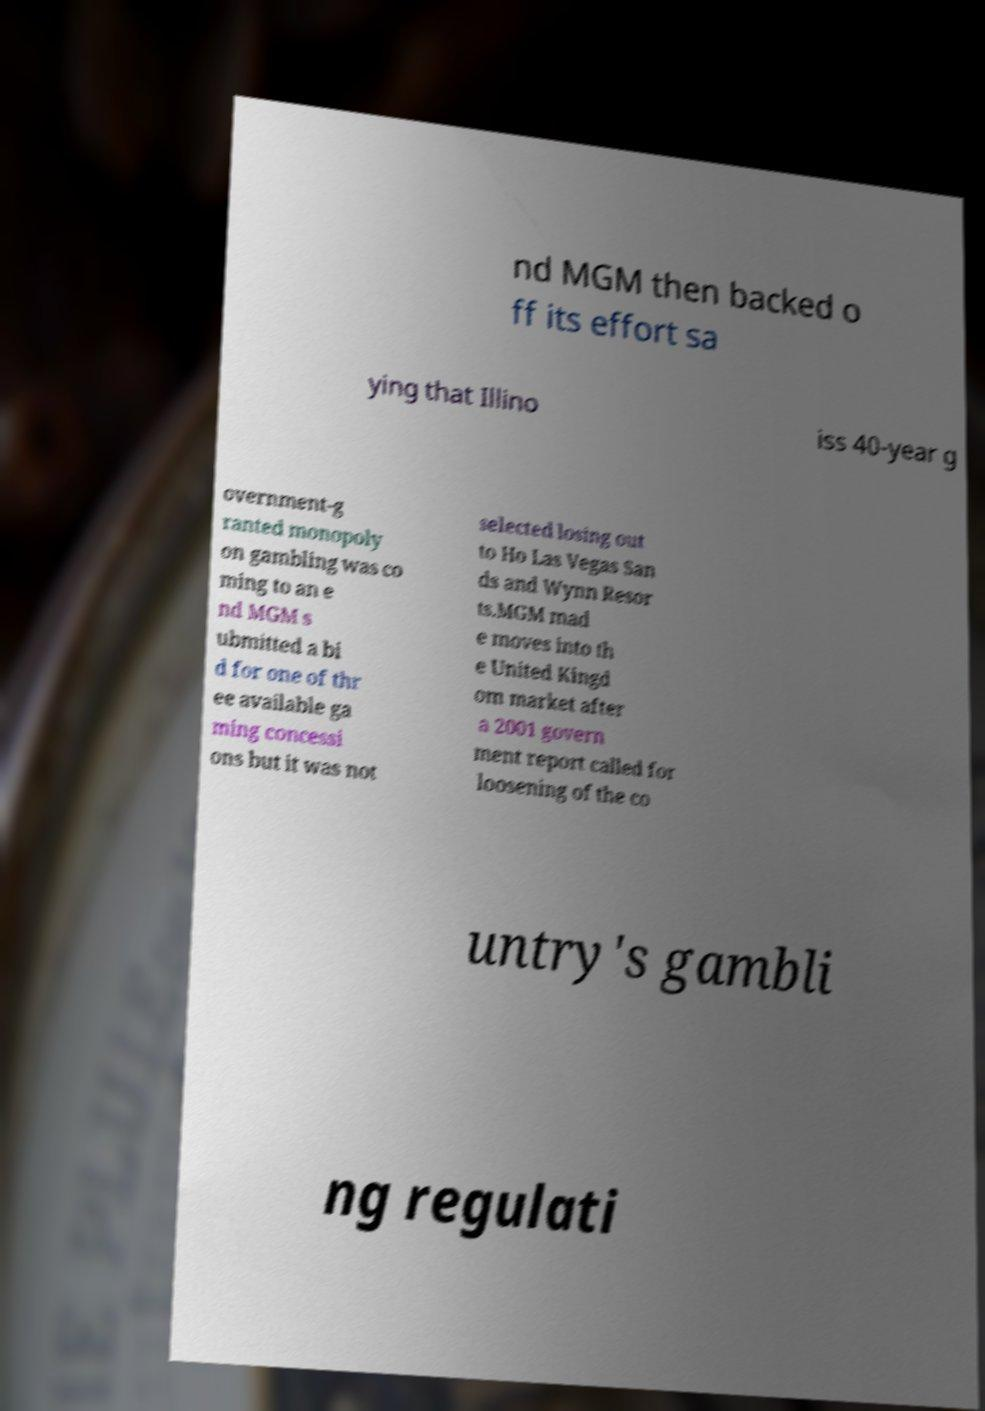Could you assist in decoding the text presented in this image and type it out clearly? nd MGM then backed o ff its effort sa ying that Illino iss 40-year g overnment-g ranted monopoly on gambling was co ming to an e nd MGM s ubmitted a bi d for one of thr ee available ga ming concessi ons but it was not selected losing out to Ho Las Vegas San ds and Wynn Resor ts.MGM mad e moves into th e United Kingd om market after a 2001 govern ment report called for loosening of the co untry's gambli ng regulati 